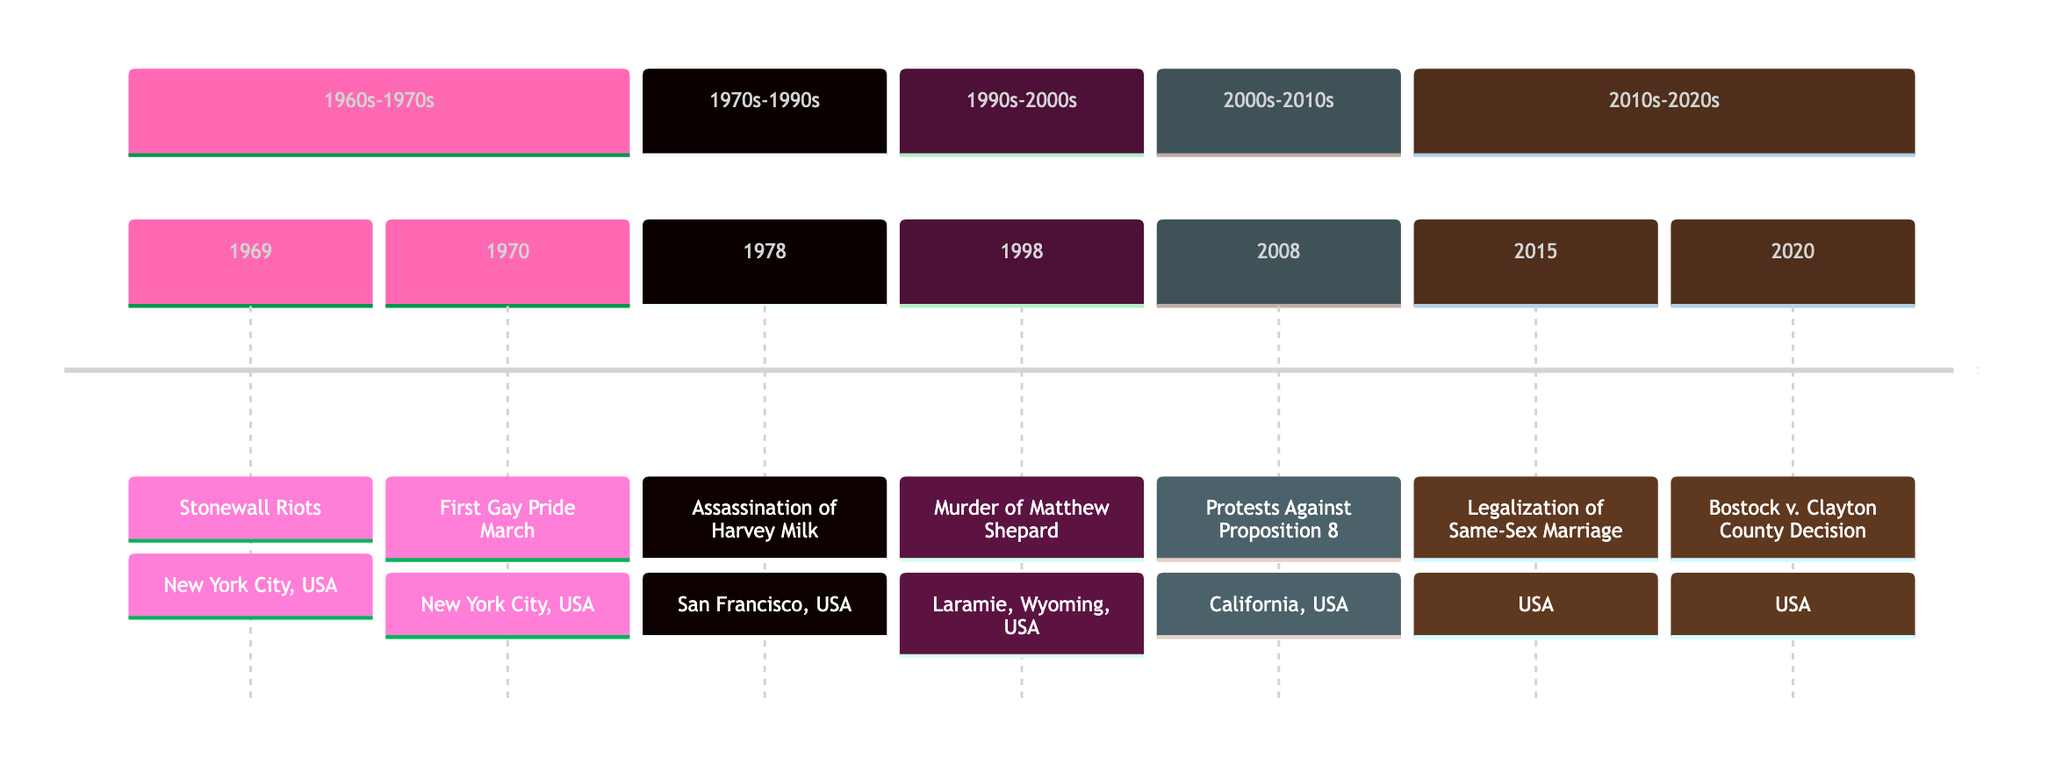What date did the Stonewall Riots occur? The diagram lists the date of the Stonewall Riots as 1969-06-28, indicating it was the first event on the timeline.
Answer: 1969-06-28 Where was the first Gay Pride March held? The timeline shows that the first Gay Pride March took place in New York City, USA, following the Stonewall Riots.
Answer: New York City, USA How many events are listed in the 1990s-2000s section? The diagram includes one event, the Murder of Matthew Shepard in 1998, in the 1990s-2000s section.
Answer: 1 What triggered protests after the assassination of Harvey Milk? The timeline states that the assassination of Harvey Milk in 1978 sparked protests and riots within the LGBTQIA+ community.
Answer: Assassination of Harvey Milk Which event's date is immediately before the legalization of same-sex marriage? The diagram shows that the protests against Proposition 8 occurred in 2008, which is directly before the 2015 legalization of same-sex marriage.
Answer: Protests Against Proposition 8 Which city experienced protests after the passage of Proposition 8? The timeline specifies that the protests against Proposition 8 took place in California, USA, following the event.
Answer: California, USA What important decision was made by the U.S. Supreme Court in 2020? The diagram indicates that the U.S. Supreme Court made a decision in Bostock v. Clayton County, ruling on workplace discrimination protection for LGBTQIA+ employees.
Answer: Bostock v. Clayton County Decision How many years passed between the Stonewall Riots and the first Gay Pride March? The timeline clearly shows that the Stonewall Riots occurred in 1969 and the first Gay Pride March in 1970, indicating a 1-year gap between these events.
Answer: 1 year What is the significance of the date June 26, 2015, in the timeline? The diagram identifies this date as when the U.S. Supreme Court ruled that same-sex marriage is a constitutional right, highlighting its significance in the LGBTQIA+ rights movement.
Answer: Legalization of Same-Sex Marriage 